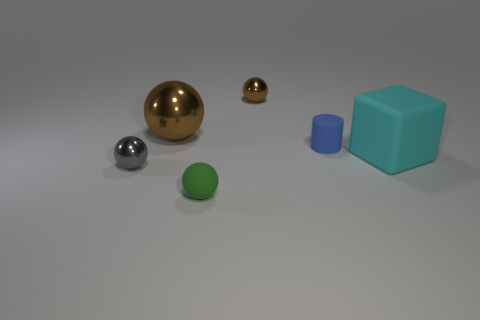Add 3 large shiny balls. How many objects exist? 9 Subtract all small brown balls. How many balls are left? 3 Subtract all brown balls. How many balls are left? 2 Subtract 1 cylinders. How many cylinders are left? 0 Subtract all blocks. How many objects are left? 5 Subtract all purple cubes. Subtract all brown cylinders. How many cubes are left? 1 Subtract all green cylinders. How many blue balls are left? 0 Subtract 0 gray cubes. How many objects are left? 6 Subtract all shiny balls. Subtract all brown objects. How many objects are left? 1 Add 2 green rubber objects. How many green rubber objects are left? 3 